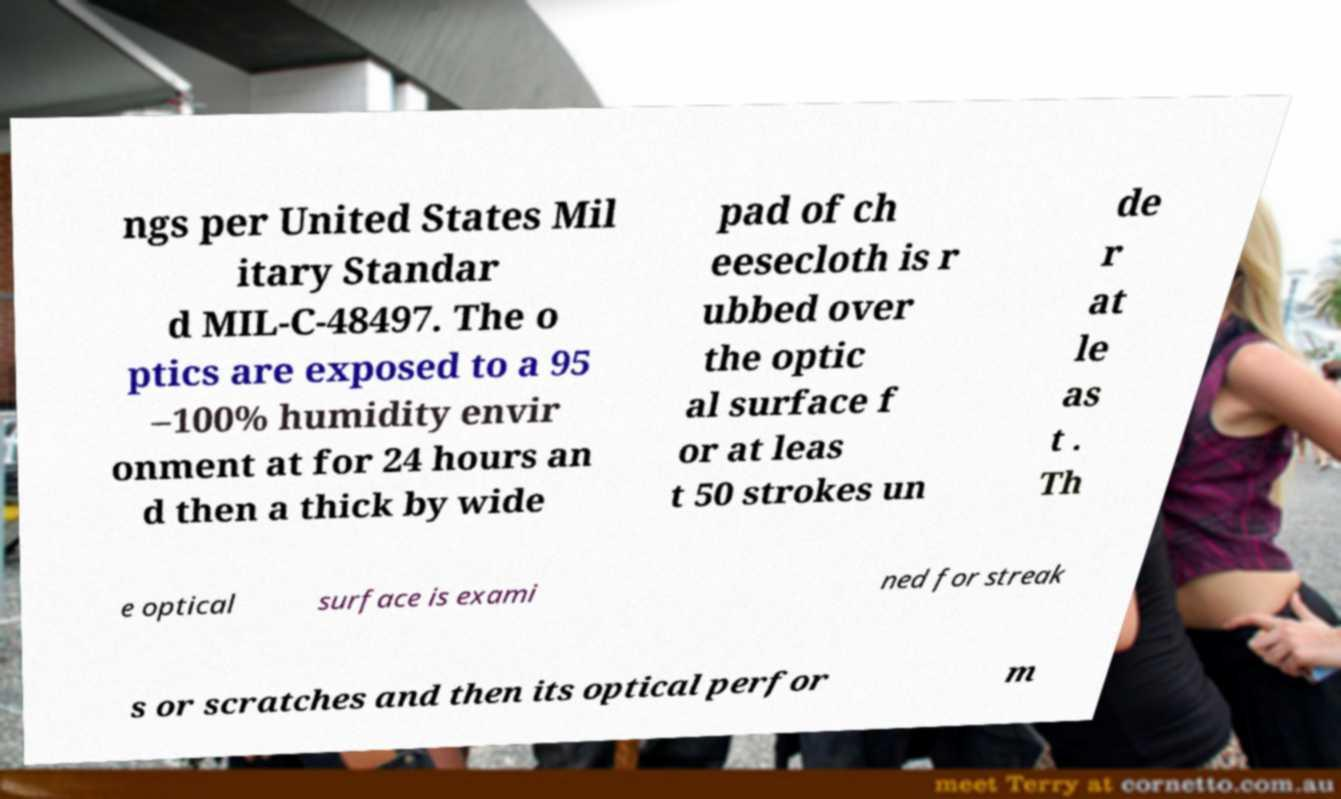Can you read and provide the text displayed in the image?This photo seems to have some interesting text. Can you extract and type it out for me? ngs per United States Mil itary Standar d MIL-C-48497. The o ptics are exposed to a 95 –100% humidity envir onment at for 24 hours an d then a thick by wide pad of ch eesecloth is r ubbed over the optic al surface f or at leas t 50 strokes un de r at le as t . Th e optical surface is exami ned for streak s or scratches and then its optical perfor m 